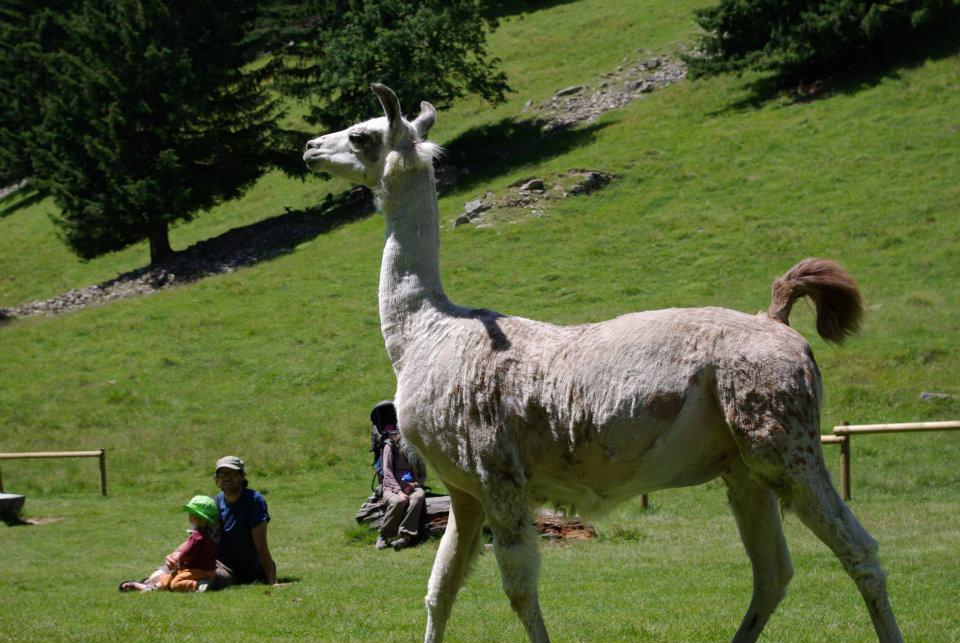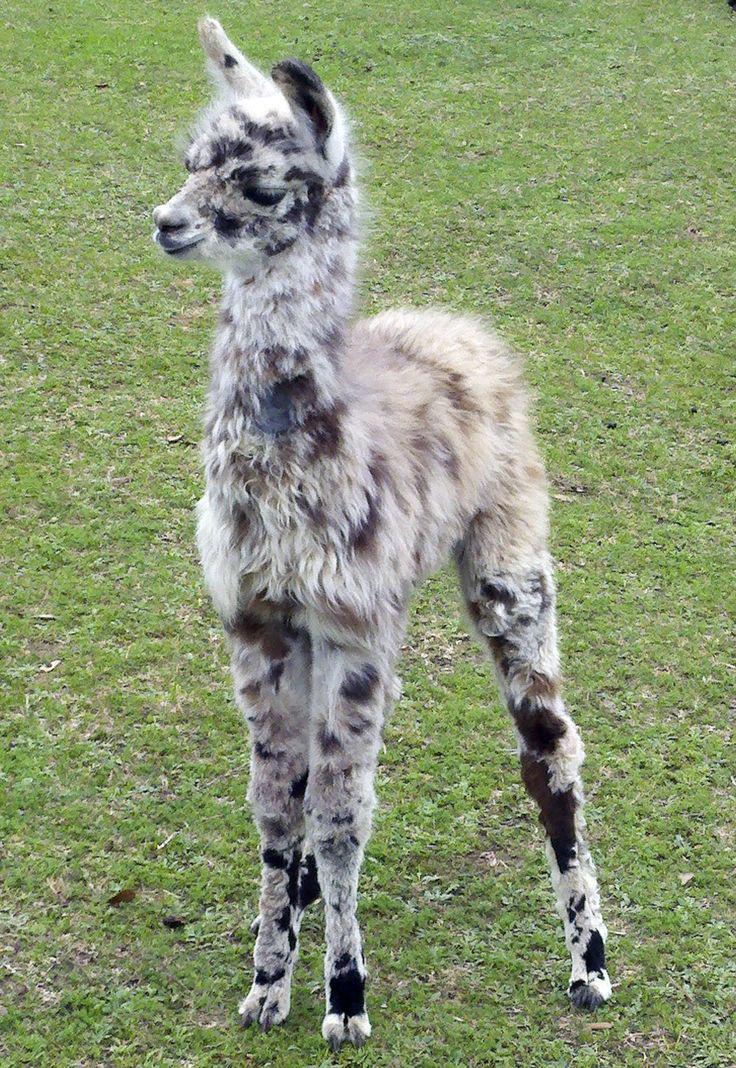The first image is the image on the left, the second image is the image on the right. Given the left and right images, does the statement "There are no more than two llamas." hold true? Answer yes or no. Yes. 